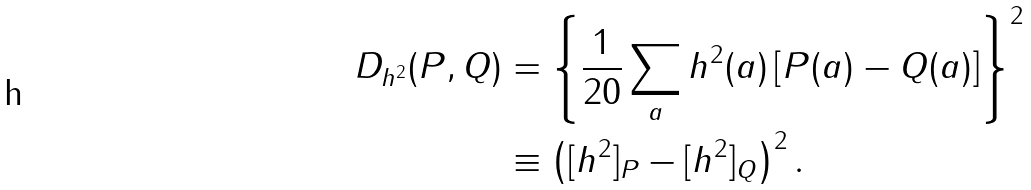Convert formula to latex. <formula><loc_0><loc_0><loc_500><loc_500>D _ { h ^ { 2 } } ( P , Q ) & = \left \{ \frac { 1 } { 2 0 } \sum _ { a } h ^ { 2 } ( a ) \left [ P ( a ) - Q ( a ) \right ] \right \} ^ { 2 } \\ & \equiv \left ( [ h ^ { 2 } ] _ { P } - [ h ^ { 2 } ] _ { Q } \right ) ^ { 2 } .</formula> 